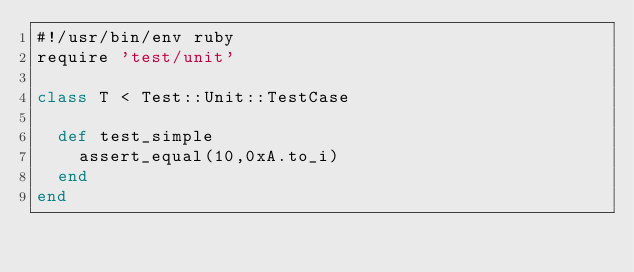Convert code to text. <code><loc_0><loc_0><loc_500><loc_500><_Ruby_>#!/usr/bin/env ruby
require 'test/unit'

class T < Test::Unit::TestCase
  
  def test_simple
    assert_equal(10,0xA.to_i)
  end
end
</code> 